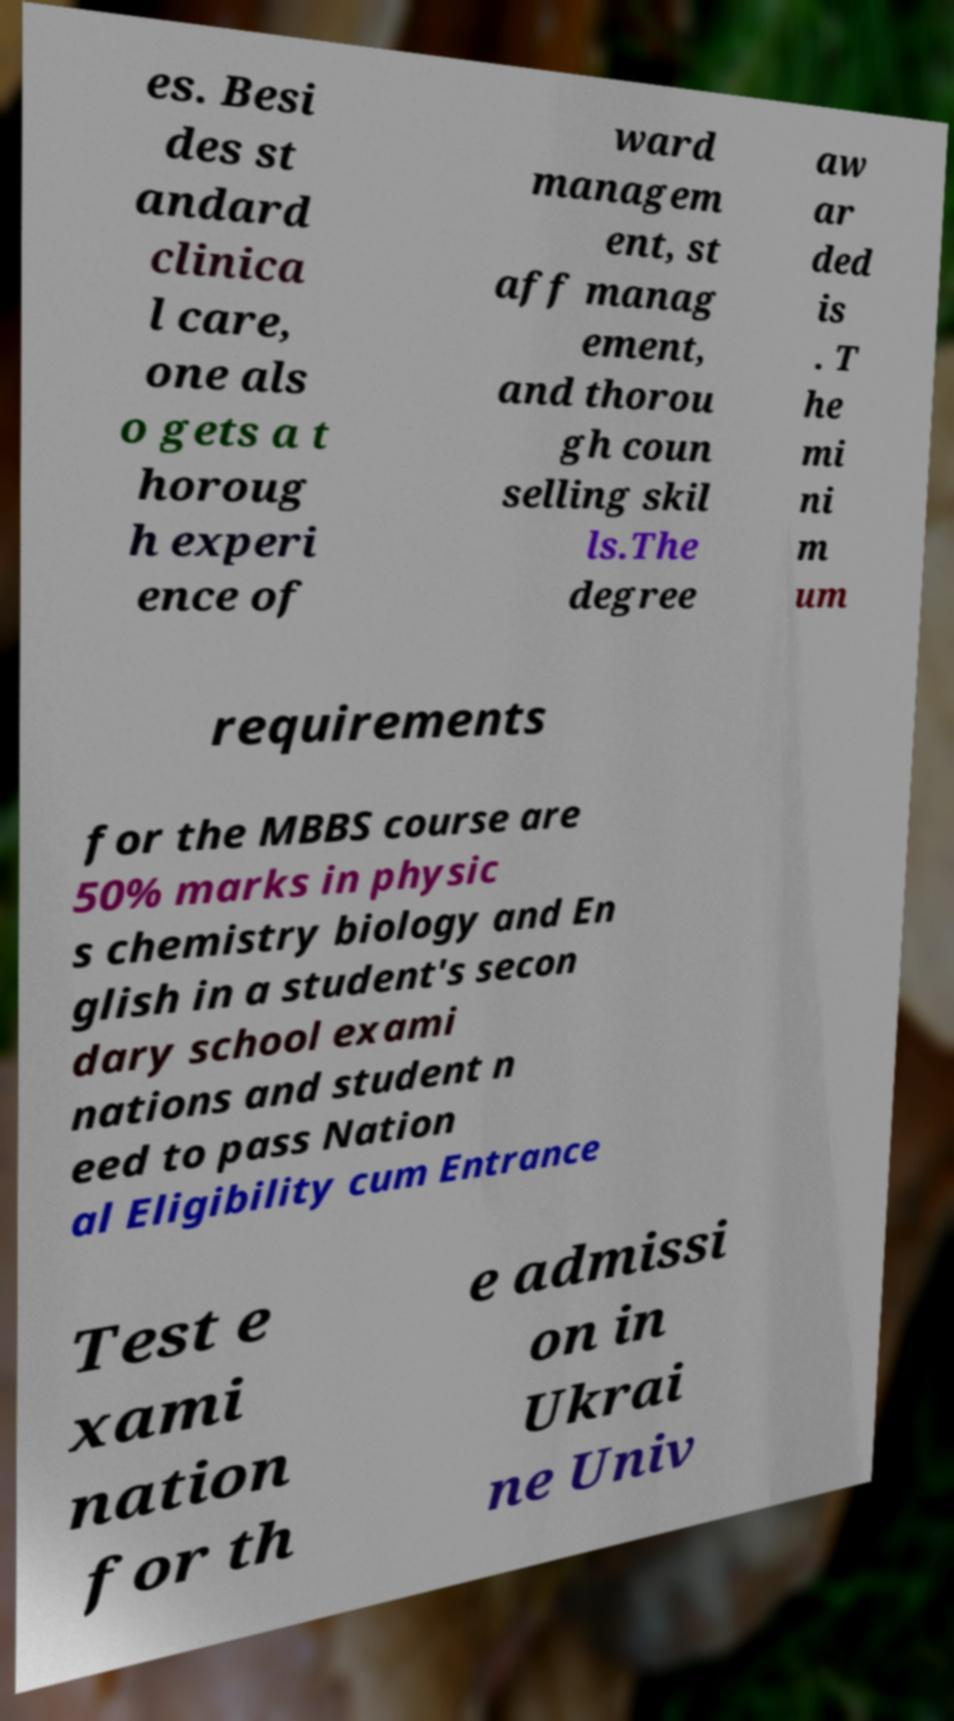What messages or text are displayed in this image? I need them in a readable, typed format. es. Besi des st andard clinica l care, one als o gets a t horoug h experi ence of ward managem ent, st aff manag ement, and thorou gh coun selling skil ls.The degree aw ar ded is . T he mi ni m um requirements for the MBBS course are 50% marks in physic s chemistry biology and En glish in a student's secon dary school exami nations and student n eed to pass Nation al Eligibility cum Entrance Test e xami nation for th e admissi on in Ukrai ne Univ 